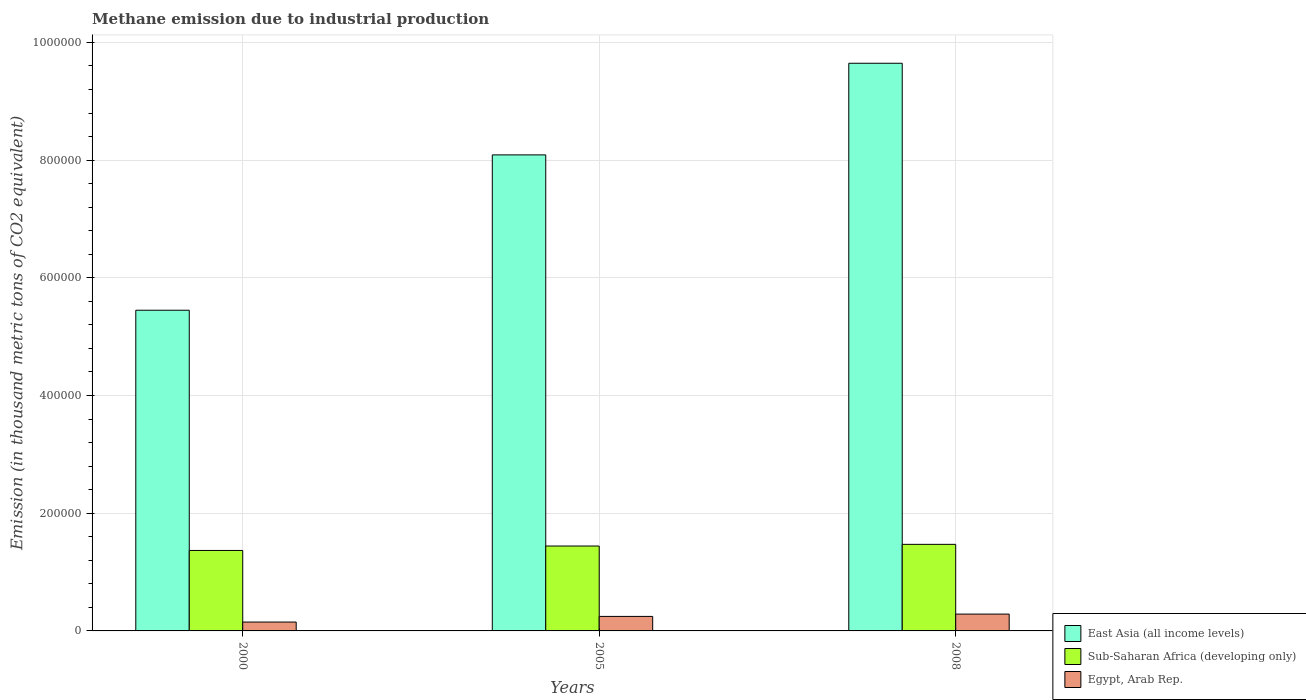How many different coloured bars are there?
Provide a short and direct response. 3. How many groups of bars are there?
Keep it short and to the point. 3. Are the number of bars on each tick of the X-axis equal?
Provide a short and direct response. Yes. What is the label of the 2nd group of bars from the left?
Ensure brevity in your answer.  2005. What is the amount of methane emitted in East Asia (all income levels) in 2000?
Offer a very short reply. 5.45e+05. Across all years, what is the maximum amount of methane emitted in Sub-Saharan Africa (developing only)?
Ensure brevity in your answer.  1.47e+05. Across all years, what is the minimum amount of methane emitted in Sub-Saharan Africa (developing only)?
Make the answer very short. 1.37e+05. In which year was the amount of methane emitted in East Asia (all income levels) maximum?
Provide a short and direct response. 2008. What is the total amount of methane emitted in Egypt, Arab Rep. in the graph?
Your answer should be very brief. 6.83e+04. What is the difference between the amount of methane emitted in East Asia (all income levels) in 2000 and that in 2005?
Keep it short and to the point. -2.64e+05. What is the difference between the amount of methane emitted in Sub-Saharan Africa (developing only) in 2000 and the amount of methane emitted in Egypt, Arab Rep. in 2008?
Provide a succinct answer. 1.08e+05. What is the average amount of methane emitted in East Asia (all income levels) per year?
Give a very brief answer. 7.73e+05. In the year 2005, what is the difference between the amount of methane emitted in East Asia (all income levels) and amount of methane emitted in Sub-Saharan Africa (developing only)?
Your response must be concise. 6.65e+05. In how many years, is the amount of methane emitted in Egypt, Arab Rep. greater than 400000 thousand metric tons?
Offer a terse response. 0. What is the ratio of the amount of methane emitted in Sub-Saharan Africa (developing only) in 2005 to that in 2008?
Offer a terse response. 0.98. Is the amount of methane emitted in East Asia (all income levels) in 2005 less than that in 2008?
Your answer should be compact. Yes. Is the difference between the amount of methane emitted in East Asia (all income levels) in 2005 and 2008 greater than the difference between the amount of methane emitted in Sub-Saharan Africa (developing only) in 2005 and 2008?
Provide a succinct answer. No. What is the difference between the highest and the second highest amount of methane emitted in Egypt, Arab Rep.?
Keep it short and to the point. 3953.4. What is the difference between the highest and the lowest amount of methane emitted in Sub-Saharan Africa (developing only)?
Ensure brevity in your answer.  1.04e+04. In how many years, is the amount of methane emitted in Egypt, Arab Rep. greater than the average amount of methane emitted in Egypt, Arab Rep. taken over all years?
Keep it short and to the point. 2. What does the 2nd bar from the left in 2008 represents?
Offer a very short reply. Sub-Saharan Africa (developing only). What does the 3rd bar from the right in 2005 represents?
Your response must be concise. East Asia (all income levels). How many bars are there?
Offer a terse response. 9. How many years are there in the graph?
Make the answer very short. 3. Are the values on the major ticks of Y-axis written in scientific E-notation?
Keep it short and to the point. No. Does the graph contain any zero values?
Provide a short and direct response. No. Where does the legend appear in the graph?
Give a very brief answer. Bottom right. What is the title of the graph?
Provide a short and direct response. Methane emission due to industrial production. What is the label or title of the Y-axis?
Your response must be concise. Emission (in thousand metric tons of CO2 equivalent). What is the Emission (in thousand metric tons of CO2 equivalent) of East Asia (all income levels) in 2000?
Give a very brief answer. 5.45e+05. What is the Emission (in thousand metric tons of CO2 equivalent) of Sub-Saharan Africa (developing only) in 2000?
Your answer should be compact. 1.37e+05. What is the Emission (in thousand metric tons of CO2 equivalent) of Egypt, Arab Rep. in 2000?
Provide a short and direct response. 1.51e+04. What is the Emission (in thousand metric tons of CO2 equivalent) in East Asia (all income levels) in 2005?
Your answer should be compact. 8.09e+05. What is the Emission (in thousand metric tons of CO2 equivalent) of Sub-Saharan Africa (developing only) in 2005?
Your response must be concise. 1.44e+05. What is the Emission (in thousand metric tons of CO2 equivalent) of Egypt, Arab Rep. in 2005?
Provide a succinct answer. 2.47e+04. What is the Emission (in thousand metric tons of CO2 equivalent) of East Asia (all income levels) in 2008?
Provide a succinct answer. 9.65e+05. What is the Emission (in thousand metric tons of CO2 equivalent) of Sub-Saharan Africa (developing only) in 2008?
Offer a very short reply. 1.47e+05. What is the Emission (in thousand metric tons of CO2 equivalent) of Egypt, Arab Rep. in 2008?
Your response must be concise. 2.86e+04. Across all years, what is the maximum Emission (in thousand metric tons of CO2 equivalent) in East Asia (all income levels)?
Offer a terse response. 9.65e+05. Across all years, what is the maximum Emission (in thousand metric tons of CO2 equivalent) of Sub-Saharan Africa (developing only)?
Give a very brief answer. 1.47e+05. Across all years, what is the maximum Emission (in thousand metric tons of CO2 equivalent) in Egypt, Arab Rep.?
Your answer should be compact. 2.86e+04. Across all years, what is the minimum Emission (in thousand metric tons of CO2 equivalent) of East Asia (all income levels)?
Your answer should be compact. 5.45e+05. Across all years, what is the minimum Emission (in thousand metric tons of CO2 equivalent) of Sub-Saharan Africa (developing only)?
Provide a short and direct response. 1.37e+05. Across all years, what is the minimum Emission (in thousand metric tons of CO2 equivalent) in Egypt, Arab Rep.?
Provide a short and direct response. 1.51e+04. What is the total Emission (in thousand metric tons of CO2 equivalent) of East Asia (all income levels) in the graph?
Make the answer very short. 2.32e+06. What is the total Emission (in thousand metric tons of CO2 equivalent) of Sub-Saharan Africa (developing only) in the graph?
Keep it short and to the point. 4.28e+05. What is the total Emission (in thousand metric tons of CO2 equivalent) in Egypt, Arab Rep. in the graph?
Offer a terse response. 6.83e+04. What is the difference between the Emission (in thousand metric tons of CO2 equivalent) in East Asia (all income levels) in 2000 and that in 2005?
Make the answer very short. -2.64e+05. What is the difference between the Emission (in thousand metric tons of CO2 equivalent) of Sub-Saharan Africa (developing only) in 2000 and that in 2005?
Offer a terse response. -7528.2. What is the difference between the Emission (in thousand metric tons of CO2 equivalent) in Egypt, Arab Rep. in 2000 and that in 2005?
Provide a succinct answer. -9607. What is the difference between the Emission (in thousand metric tons of CO2 equivalent) of East Asia (all income levels) in 2000 and that in 2008?
Your answer should be compact. -4.20e+05. What is the difference between the Emission (in thousand metric tons of CO2 equivalent) of Sub-Saharan Africa (developing only) in 2000 and that in 2008?
Give a very brief answer. -1.04e+04. What is the difference between the Emission (in thousand metric tons of CO2 equivalent) of Egypt, Arab Rep. in 2000 and that in 2008?
Provide a succinct answer. -1.36e+04. What is the difference between the Emission (in thousand metric tons of CO2 equivalent) in East Asia (all income levels) in 2005 and that in 2008?
Your response must be concise. -1.56e+05. What is the difference between the Emission (in thousand metric tons of CO2 equivalent) of Sub-Saharan Africa (developing only) in 2005 and that in 2008?
Your response must be concise. -2859.6. What is the difference between the Emission (in thousand metric tons of CO2 equivalent) in Egypt, Arab Rep. in 2005 and that in 2008?
Keep it short and to the point. -3953.4. What is the difference between the Emission (in thousand metric tons of CO2 equivalent) of East Asia (all income levels) in 2000 and the Emission (in thousand metric tons of CO2 equivalent) of Sub-Saharan Africa (developing only) in 2005?
Provide a succinct answer. 4.01e+05. What is the difference between the Emission (in thousand metric tons of CO2 equivalent) in East Asia (all income levels) in 2000 and the Emission (in thousand metric tons of CO2 equivalent) in Egypt, Arab Rep. in 2005?
Keep it short and to the point. 5.20e+05. What is the difference between the Emission (in thousand metric tons of CO2 equivalent) in Sub-Saharan Africa (developing only) in 2000 and the Emission (in thousand metric tons of CO2 equivalent) in Egypt, Arab Rep. in 2005?
Offer a very short reply. 1.12e+05. What is the difference between the Emission (in thousand metric tons of CO2 equivalent) in East Asia (all income levels) in 2000 and the Emission (in thousand metric tons of CO2 equivalent) in Sub-Saharan Africa (developing only) in 2008?
Give a very brief answer. 3.98e+05. What is the difference between the Emission (in thousand metric tons of CO2 equivalent) in East Asia (all income levels) in 2000 and the Emission (in thousand metric tons of CO2 equivalent) in Egypt, Arab Rep. in 2008?
Provide a succinct answer. 5.16e+05. What is the difference between the Emission (in thousand metric tons of CO2 equivalent) of Sub-Saharan Africa (developing only) in 2000 and the Emission (in thousand metric tons of CO2 equivalent) of Egypt, Arab Rep. in 2008?
Make the answer very short. 1.08e+05. What is the difference between the Emission (in thousand metric tons of CO2 equivalent) in East Asia (all income levels) in 2005 and the Emission (in thousand metric tons of CO2 equivalent) in Sub-Saharan Africa (developing only) in 2008?
Offer a very short reply. 6.62e+05. What is the difference between the Emission (in thousand metric tons of CO2 equivalent) in East Asia (all income levels) in 2005 and the Emission (in thousand metric tons of CO2 equivalent) in Egypt, Arab Rep. in 2008?
Give a very brief answer. 7.80e+05. What is the difference between the Emission (in thousand metric tons of CO2 equivalent) of Sub-Saharan Africa (developing only) in 2005 and the Emission (in thousand metric tons of CO2 equivalent) of Egypt, Arab Rep. in 2008?
Your answer should be compact. 1.16e+05. What is the average Emission (in thousand metric tons of CO2 equivalent) in East Asia (all income levels) per year?
Offer a very short reply. 7.73e+05. What is the average Emission (in thousand metric tons of CO2 equivalent) in Sub-Saharan Africa (developing only) per year?
Give a very brief answer. 1.43e+05. What is the average Emission (in thousand metric tons of CO2 equivalent) in Egypt, Arab Rep. per year?
Give a very brief answer. 2.28e+04. In the year 2000, what is the difference between the Emission (in thousand metric tons of CO2 equivalent) of East Asia (all income levels) and Emission (in thousand metric tons of CO2 equivalent) of Sub-Saharan Africa (developing only)?
Make the answer very short. 4.08e+05. In the year 2000, what is the difference between the Emission (in thousand metric tons of CO2 equivalent) in East Asia (all income levels) and Emission (in thousand metric tons of CO2 equivalent) in Egypt, Arab Rep.?
Your answer should be very brief. 5.30e+05. In the year 2000, what is the difference between the Emission (in thousand metric tons of CO2 equivalent) in Sub-Saharan Africa (developing only) and Emission (in thousand metric tons of CO2 equivalent) in Egypt, Arab Rep.?
Offer a terse response. 1.22e+05. In the year 2005, what is the difference between the Emission (in thousand metric tons of CO2 equivalent) of East Asia (all income levels) and Emission (in thousand metric tons of CO2 equivalent) of Sub-Saharan Africa (developing only)?
Your answer should be compact. 6.65e+05. In the year 2005, what is the difference between the Emission (in thousand metric tons of CO2 equivalent) in East Asia (all income levels) and Emission (in thousand metric tons of CO2 equivalent) in Egypt, Arab Rep.?
Your answer should be compact. 7.84e+05. In the year 2005, what is the difference between the Emission (in thousand metric tons of CO2 equivalent) of Sub-Saharan Africa (developing only) and Emission (in thousand metric tons of CO2 equivalent) of Egypt, Arab Rep.?
Your answer should be very brief. 1.20e+05. In the year 2008, what is the difference between the Emission (in thousand metric tons of CO2 equivalent) of East Asia (all income levels) and Emission (in thousand metric tons of CO2 equivalent) of Sub-Saharan Africa (developing only)?
Your answer should be very brief. 8.18e+05. In the year 2008, what is the difference between the Emission (in thousand metric tons of CO2 equivalent) of East Asia (all income levels) and Emission (in thousand metric tons of CO2 equivalent) of Egypt, Arab Rep.?
Your response must be concise. 9.36e+05. In the year 2008, what is the difference between the Emission (in thousand metric tons of CO2 equivalent) in Sub-Saharan Africa (developing only) and Emission (in thousand metric tons of CO2 equivalent) in Egypt, Arab Rep.?
Provide a succinct answer. 1.19e+05. What is the ratio of the Emission (in thousand metric tons of CO2 equivalent) of East Asia (all income levels) in 2000 to that in 2005?
Give a very brief answer. 0.67. What is the ratio of the Emission (in thousand metric tons of CO2 equivalent) in Sub-Saharan Africa (developing only) in 2000 to that in 2005?
Offer a terse response. 0.95. What is the ratio of the Emission (in thousand metric tons of CO2 equivalent) in Egypt, Arab Rep. in 2000 to that in 2005?
Offer a very short reply. 0.61. What is the ratio of the Emission (in thousand metric tons of CO2 equivalent) in East Asia (all income levels) in 2000 to that in 2008?
Offer a very short reply. 0.56. What is the ratio of the Emission (in thousand metric tons of CO2 equivalent) of Sub-Saharan Africa (developing only) in 2000 to that in 2008?
Your answer should be compact. 0.93. What is the ratio of the Emission (in thousand metric tons of CO2 equivalent) of Egypt, Arab Rep. in 2000 to that in 2008?
Give a very brief answer. 0.53. What is the ratio of the Emission (in thousand metric tons of CO2 equivalent) of East Asia (all income levels) in 2005 to that in 2008?
Give a very brief answer. 0.84. What is the ratio of the Emission (in thousand metric tons of CO2 equivalent) in Sub-Saharan Africa (developing only) in 2005 to that in 2008?
Offer a terse response. 0.98. What is the ratio of the Emission (in thousand metric tons of CO2 equivalent) in Egypt, Arab Rep. in 2005 to that in 2008?
Your answer should be compact. 0.86. What is the difference between the highest and the second highest Emission (in thousand metric tons of CO2 equivalent) of East Asia (all income levels)?
Your response must be concise. 1.56e+05. What is the difference between the highest and the second highest Emission (in thousand metric tons of CO2 equivalent) of Sub-Saharan Africa (developing only)?
Offer a very short reply. 2859.6. What is the difference between the highest and the second highest Emission (in thousand metric tons of CO2 equivalent) of Egypt, Arab Rep.?
Give a very brief answer. 3953.4. What is the difference between the highest and the lowest Emission (in thousand metric tons of CO2 equivalent) of East Asia (all income levels)?
Provide a succinct answer. 4.20e+05. What is the difference between the highest and the lowest Emission (in thousand metric tons of CO2 equivalent) in Sub-Saharan Africa (developing only)?
Offer a terse response. 1.04e+04. What is the difference between the highest and the lowest Emission (in thousand metric tons of CO2 equivalent) of Egypt, Arab Rep.?
Give a very brief answer. 1.36e+04. 